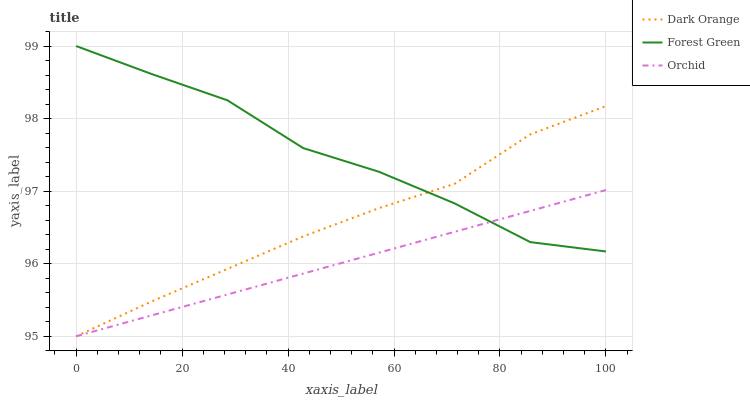Does Orchid have the minimum area under the curve?
Answer yes or no. Yes. Does Forest Green have the maximum area under the curve?
Answer yes or no. Yes. Does Forest Green have the minimum area under the curve?
Answer yes or no. No. Does Orchid have the maximum area under the curve?
Answer yes or no. No. Is Orchid the smoothest?
Answer yes or no. Yes. Is Forest Green the roughest?
Answer yes or no. Yes. Is Forest Green the smoothest?
Answer yes or no. No. Is Orchid the roughest?
Answer yes or no. No. Does Dark Orange have the lowest value?
Answer yes or no. Yes. Does Forest Green have the lowest value?
Answer yes or no. No. Does Forest Green have the highest value?
Answer yes or no. Yes. Does Orchid have the highest value?
Answer yes or no. No. Does Dark Orange intersect Forest Green?
Answer yes or no. Yes. Is Dark Orange less than Forest Green?
Answer yes or no. No. Is Dark Orange greater than Forest Green?
Answer yes or no. No. 